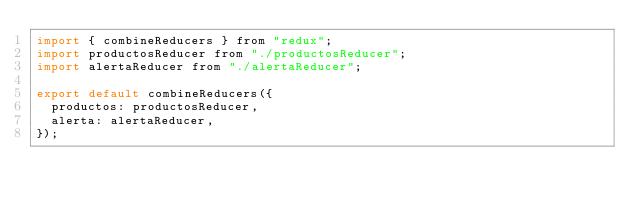Convert code to text. <code><loc_0><loc_0><loc_500><loc_500><_JavaScript_>import { combineReducers } from "redux";
import productosReducer from "./productosReducer";
import alertaReducer from "./alertaReducer";

export default combineReducers({
  productos: productosReducer,
  alerta: alertaReducer,
});
</code> 